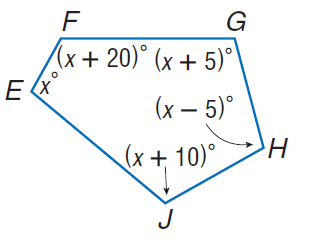Answer the mathemtical geometry problem and directly provide the correct option letter.
Question: Find m \angle G.
Choices: A: 102 B: 107 C: 112 D: 122 B 